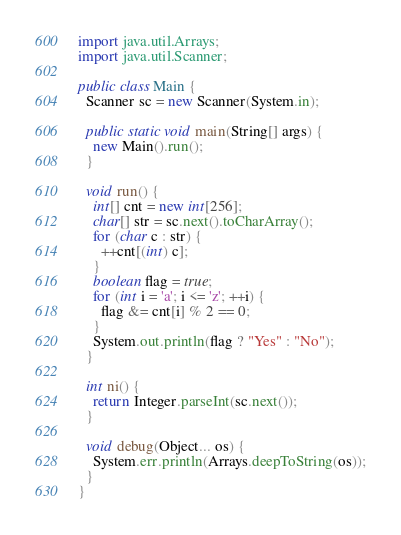Convert code to text. <code><loc_0><loc_0><loc_500><loc_500><_Java_>import java.util.Arrays;
import java.util.Scanner;

public class Main {
  Scanner sc = new Scanner(System.in);

  public static void main(String[] args) {
    new Main().run();
  }

  void run() {
    int[] cnt = new int[256];
    char[] str = sc.next().toCharArray();
    for (char c : str) {
      ++cnt[(int) c];
    }
    boolean flag = true;
    for (int i = 'a'; i <= 'z'; ++i) {
      flag &= cnt[i] % 2 == 0;
    }
    System.out.println(flag ? "Yes" : "No");
  }

  int ni() {
    return Integer.parseInt(sc.next());
  }

  void debug(Object... os) {
    System.err.println(Arrays.deepToString(os));
  }
}</code> 